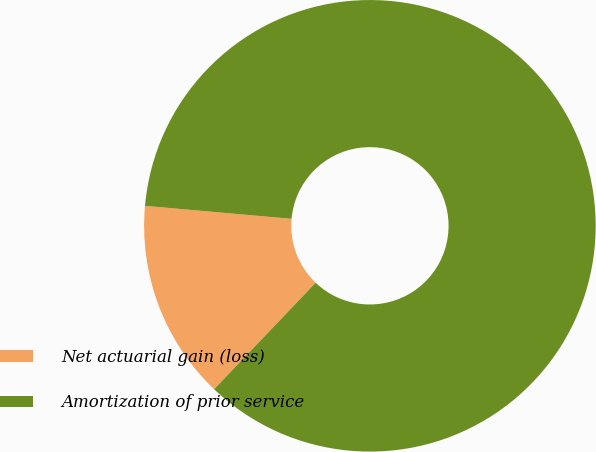Convert chart. <chart><loc_0><loc_0><loc_500><loc_500><pie_chart><fcel>Net actuarial gain (loss)<fcel>Amortization of prior service<nl><fcel>14.29%<fcel>85.71%<nl></chart> 